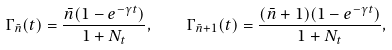Convert formula to latex. <formula><loc_0><loc_0><loc_500><loc_500>\Gamma _ { \bar { n } } ( t ) = \frac { \bar { n } ( 1 - e ^ { - \gamma t } ) } { 1 + N _ { t } } , \quad \Gamma _ { \bar { n } + 1 } ( t ) = \frac { ( \bar { n } + 1 ) ( 1 - e ^ { - \gamma t } ) } { 1 + N _ { t } } ,</formula> 